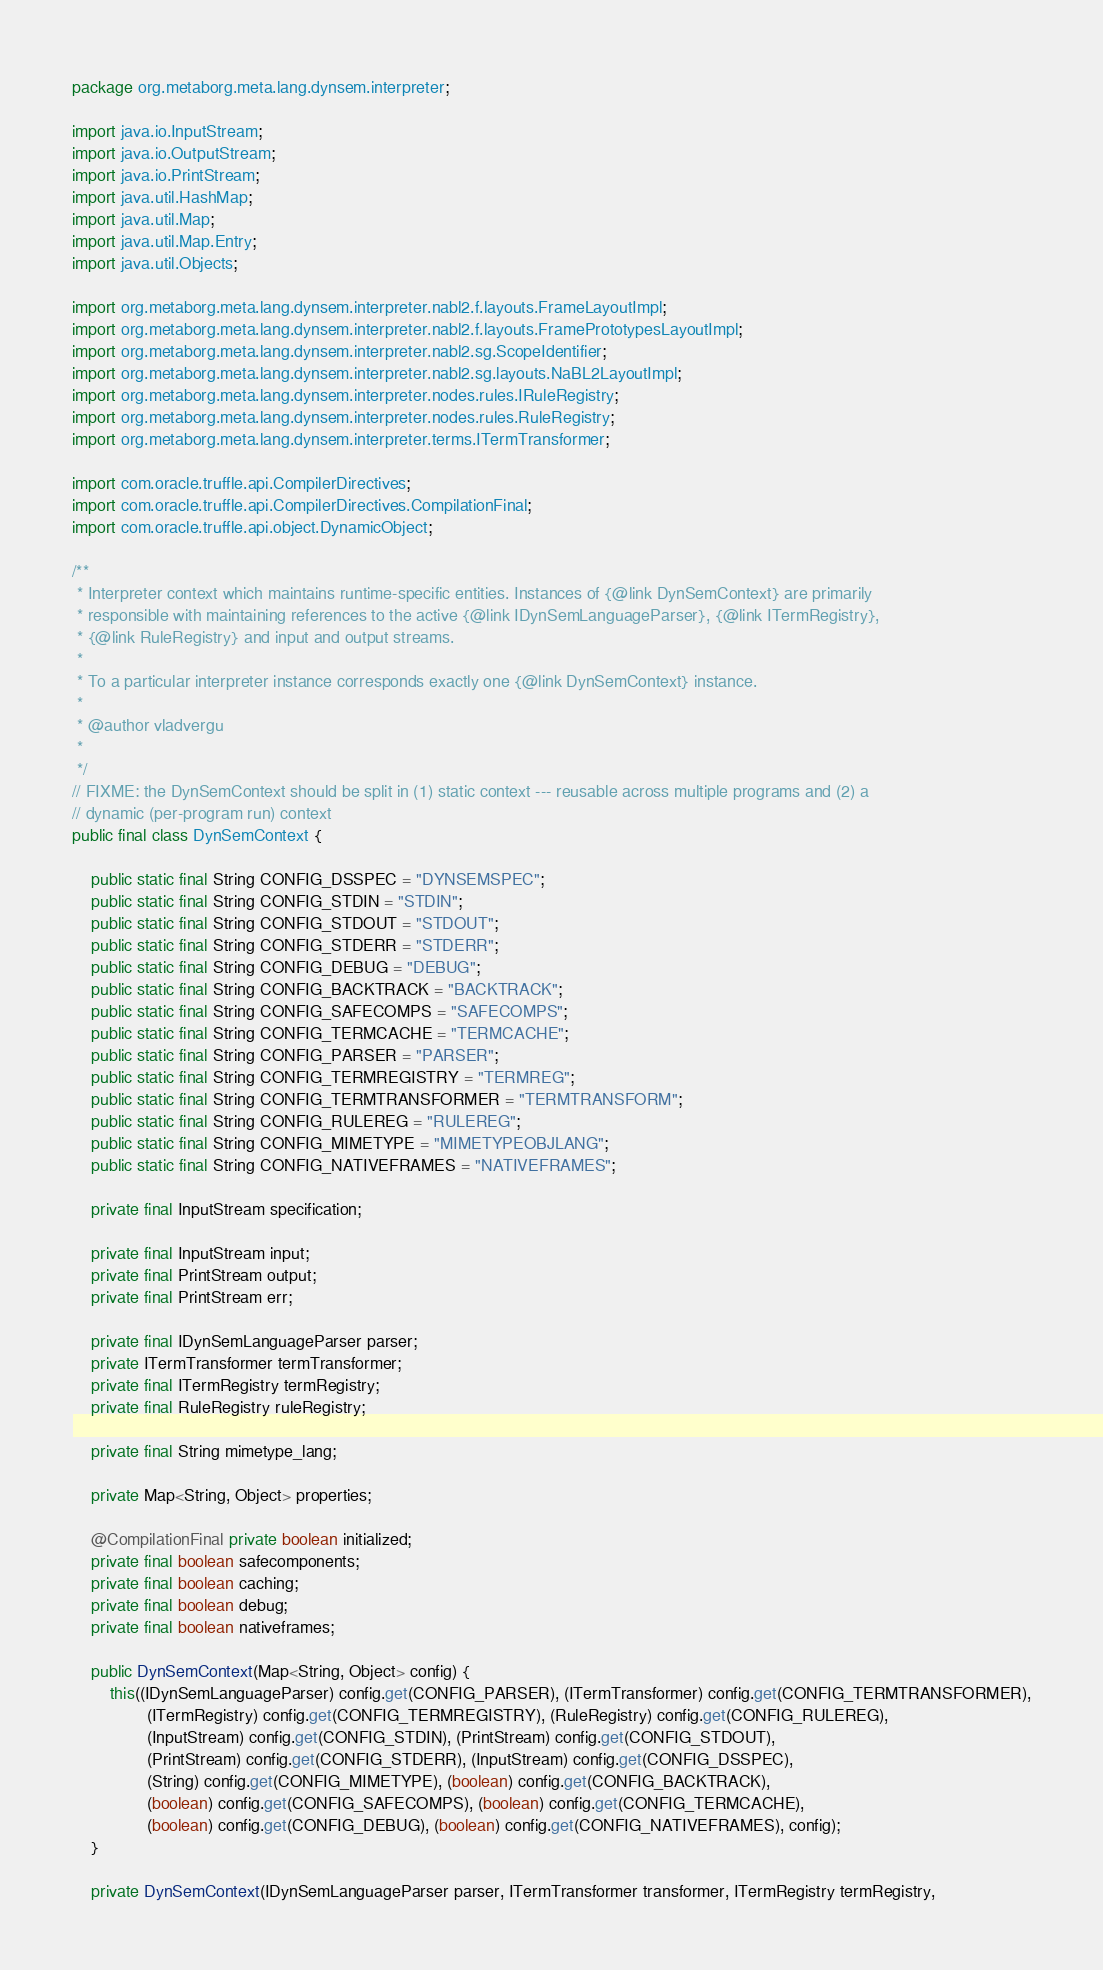Convert code to text. <code><loc_0><loc_0><loc_500><loc_500><_Java_>package org.metaborg.meta.lang.dynsem.interpreter;

import java.io.InputStream;
import java.io.OutputStream;
import java.io.PrintStream;
import java.util.HashMap;
import java.util.Map;
import java.util.Map.Entry;
import java.util.Objects;

import org.metaborg.meta.lang.dynsem.interpreter.nabl2.f.layouts.FrameLayoutImpl;
import org.metaborg.meta.lang.dynsem.interpreter.nabl2.f.layouts.FramePrototypesLayoutImpl;
import org.metaborg.meta.lang.dynsem.interpreter.nabl2.sg.ScopeIdentifier;
import org.metaborg.meta.lang.dynsem.interpreter.nabl2.sg.layouts.NaBL2LayoutImpl;
import org.metaborg.meta.lang.dynsem.interpreter.nodes.rules.IRuleRegistry;
import org.metaborg.meta.lang.dynsem.interpreter.nodes.rules.RuleRegistry;
import org.metaborg.meta.lang.dynsem.interpreter.terms.ITermTransformer;

import com.oracle.truffle.api.CompilerDirectives;
import com.oracle.truffle.api.CompilerDirectives.CompilationFinal;
import com.oracle.truffle.api.object.DynamicObject;

/**
 * Interpreter context which maintains runtime-specific entities. Instances of {@link DynSemContext} are primarily
 * responsible with maintaining references to the active {@link IDynSemLanguageParser}, {@link ITermRegistry},
 * {@link RuleRegistry} and input and output streams.
 * 
 * To a particular interpreter instance corresponds exactly one {@link DynSemContext} instance.
 * 
 * @author vladvergu
 *
 */
// FIXME: the DynSemContext should be split in (1) static context --- reusable across multiple programs and (2) a
// dynamic (per-program run) context
public final class DynSemContext {

	public static final String CONFIG_DSSPEC = "DYNSEMSPEC";
	public static final String CONFIG_STDIN = "STDIN";
	public static final String CONFIG_STDOUT = "STDOUT";
	public static final String CONFIG_STDERR = "STDERR";
	public static final String CONFIG_DEBUG = "DEBUG";
	public static final String CONFIG_BACKTRACK = "BACKTRACK";
	public static final String CONFIG_SAFECOMPS = "SAFECOMPS";
	public static final String CONFIG_TERMCACHE = "TERMCACHE";
	public static final String CONFIG_PARSER = "PARSER";
	public static final String CONFIG_TERMREGISTRY = "TERMREG";
	public static final String CONFIG_TERMTRANSFORMER = "TERMTRANSFORM";
	public static final String CONFIG_RULEREG = "RULEREG";
	public static final String CONFIG_MIMETYPE = "MIMETYPEOBJLANG";
	public static final String CONFIG_NATIVEFRAMES = "NATIVEFRAMES";

	private final InputStream specification;

	private final InputStream input;
	private final PrintStream output;
	private final PrintStream err;

	private final IDynSemLanguageParser parser;
	private ITermTransformer termTransformer;
	private final ITermRegistry termRegistry;
	private final RuleRegistry ruleRegistry;

	private final String mimetype_lang;

	private Map<String, Object> properties;

	@CompilationFinal private boolean initialized;
	private final boolean safecomponents;
	private final boolean caching;
	private final boolean debug;
	private final boolean nativeframes;

	public DynSemContext(Map<String, Object> config) {
		this((IDynSemLanguageParser) config.get(CONFIG_PARSER), (ITermTransformer) config.get(CONFIG_TERMTRANSFORMER),
				(ITermRegistry) config.get(CONFIG_TERMREGISTRY), (RuleRegistry) config.get(CONFIG_RULEREG),
				(InputStream) config.get(CONFIG_STDIN), (PrintStream) config.get(CONFIG_STDOUT),
				(PrintStream) config.get(CONFIG_STDERR), (InputStream) config.get(CONFIG_DSSPEC),
				(String) config.get(CONFIG_MIMETYPE), (boolean) config.get(CONFIG_BACKTRACK),
				(boolean) config.get(CONFIG_SAFECOMPS), (boolean) config.get(CONFIG_TERMCACHE),
				(boolean) config.get(CONFIG_DEBUG), (boolean) config.get(CONFIG_NATIVEFRAMES), config);
	}

	private DynSemContext(IDynSemLanguageParser parser, ITermTransformer transformer, ITermRegistry termRegistry,</code> 